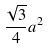<formula> <loc_0><loc_0><loc_500><loc_500>\frac { \sqrt { 3 } } { 4 } a ^ { 2 }</formula> 